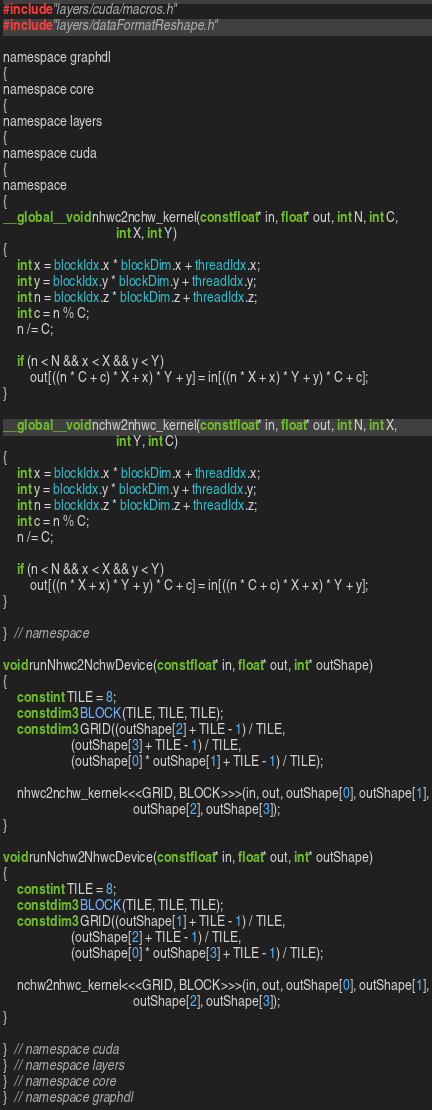Convert code to text. <code><loc_0><loc_0><loc_500><loc_500><_Cuda_>#include "layers/cuda/macros.h"
#include "layers/dataFormatReshape.h"

namespace graphdl
{
namespace core
{
namespace layers
{
namespace cuda
{
namespace
{
__global__ void nhwc2nchw_kernel(const float* in, float* out, int N, int C,
                                 int X, int Y)
{
    int x = blockIdx.x * blockDim.x + threadIdx.x;
    int y = blockIdx.y * blockDim.y + threadIdx.y;
    int n = blockIdx.z * blockDim.z + threadIdx.z;
    int c = n % C;
    n /= C;

    if (n < N && x < X && y < Y)
        out[((n * C + c) * X + x) * Y + y] = in[((n * X + x) * Y + y) * C + c];
}

__global__ void nchw2nhwc_kernel(const float* in, float* out, int N, int X,
                                 int Y, int C)
{
    int x = blockIdx.x * blockDim.x + threadIdx.x;
    int y = blockIdx.y * blockDim.y + threadIdx.y;
    int n = blockIdx.z * blockDim.z + threadIdx.z;
    int c = n % C;
    n /= C;

    if (n < N && x < X && y < Y)
        out[((n * X + x) * Y + y) * C + c] = in[((n * C + c) * X + x) * Y + y];
}

}  // namespace

void runNhwc2NchwDevice(const float* in, float* out, int* outShape)
{
    const int TILE = 8;
    const dim3 BLOCK(TILE, TILE, TILE);
    const dim3 GRID((outShape[2] + TILE - 1) / TILE,
                    (outShape[3] + TILE - 1) / TILE,
                    (outShape[0] * outShape[1] + TILE - 1) / TILE);

    nhwc2nchw_kernel<<<GRID, BLOCK>>>(in, out, outShape[0], outShape[1],
                                      outShape[2], outShape[3]);
}

void runNchw2NhwcDevice(const float* in, float* out, int* outShape)
{
    const int TILE = 8;
    const dim3 BLOCK(TILE, TILE, TILE);
    const dim3 GRID((outShape[1] + TILE - 1) / TILE,
                    (outShape[2] + TILE - 1) / TILE,
                    (outShape[0] * outShape[3] + TILE - 1) / TILE);

    nchw2nhwc_kernel<<<GRID, BLOCK>>>(in, out, outShape[0], outShape[1],
                                      outShape[2], outShape[3]);
}

}  // namespace cuda
}  // namespace layers
}  // namespace core
}  // namespace graphdl
</code> 